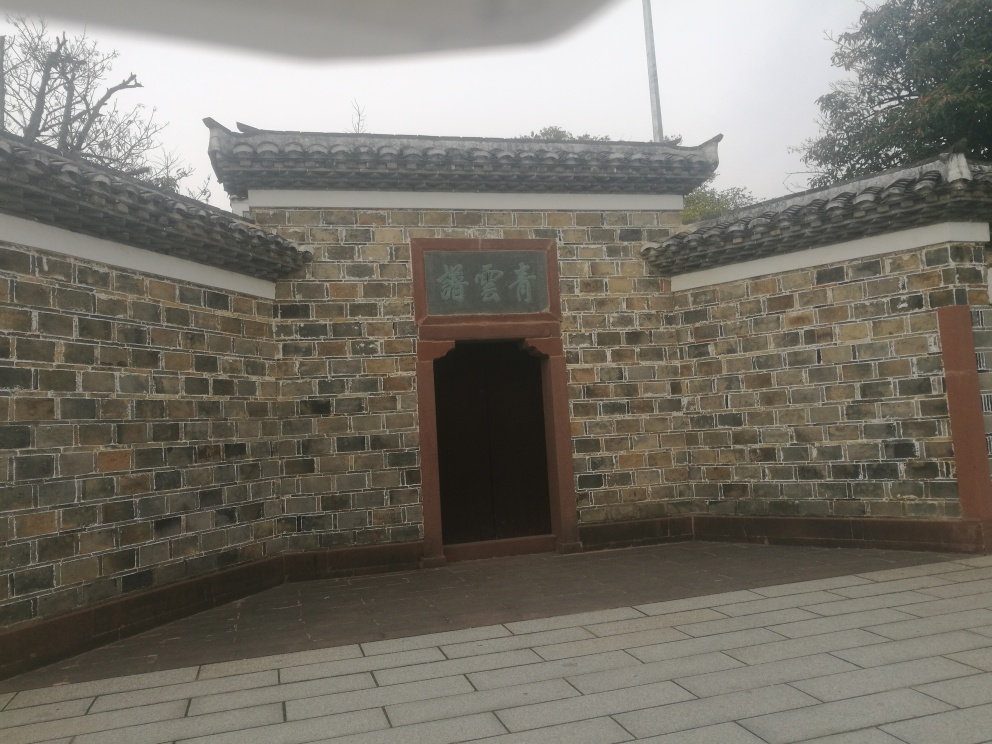Are there any quality issues with this image? The image presents a few quality issues. For instance, it appears to be slightly blurry and lacking in fine detail which may affect our ability to analyze intricate aspects such as the texture of the wall or the exact characters on the sign. Additionally, there seems to be a slight vignetting on the borders, possibly due to a finger partially covering the lens or some other obstruction. 